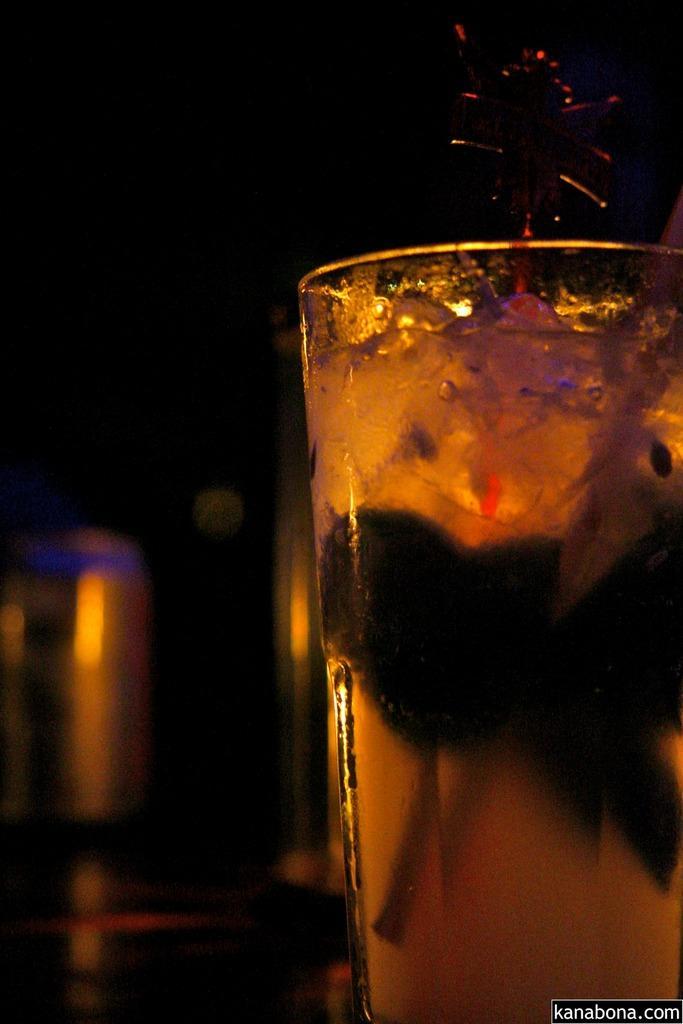In one or two sentences, can you explain what this image depicts? In this image we can see a glass and juice in it. 